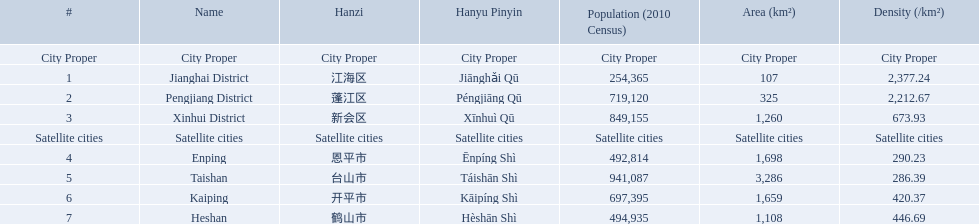What are all the cities? Jianghai District, Pengjiang District, Xinhui District, Enping, Taishan, Kaiping, Heshan. Of these, which are satellite cities? Enping, Taishan, Kaiping, Heshan. For these, what are their populations? 492,814, 941,087, 697,395, 494,935. Of these, which is the largest? 941,087. Which city has this population? Taishan. What are the subsidiary cities of jiangmen? Enping, Taishan, Kaiping, Heshan. Among these cities, which has the greatest density? Taishan. What are all the urban areas? Jianghai District, Pengjiang District, Xinhui District, Enping, Taishan, Kaiping, Heshan. Of these, which are categorized as satellite cities? Enping, Taishan, Kaiping, Heshan. For these, what are their population figures? 492,814, 941,087, 697,395, 494,935. Of these, which has the highest population? 941,087. Which city possesses this population? Taishan. What towns can be found in jiangmen? Jianghai District, Pengjiang District, Xinhui District, Enping, Taishan, Kaiping, Heshan. Out of those, which ones are considered a proper city? Jianghai District, Pengjiang District, Xinhui District. Out of those, which one occupies the smallest area in km2? Jianghai District. 